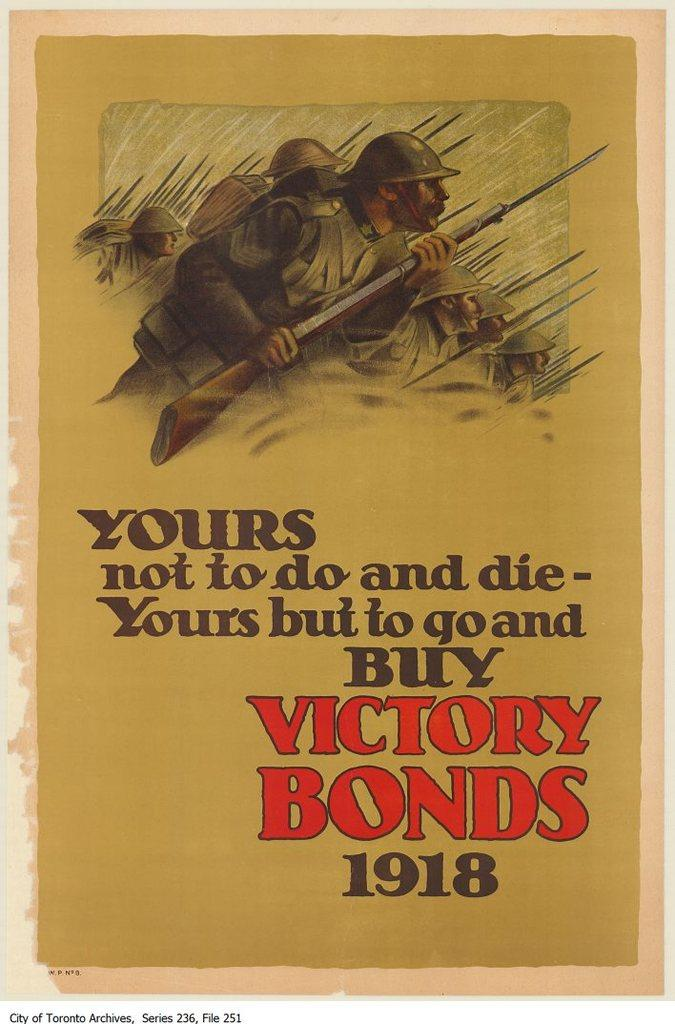<image>
Create a compact narrative representing the image presented. A 1918 advertisement asking people to purchase victory bonds. 